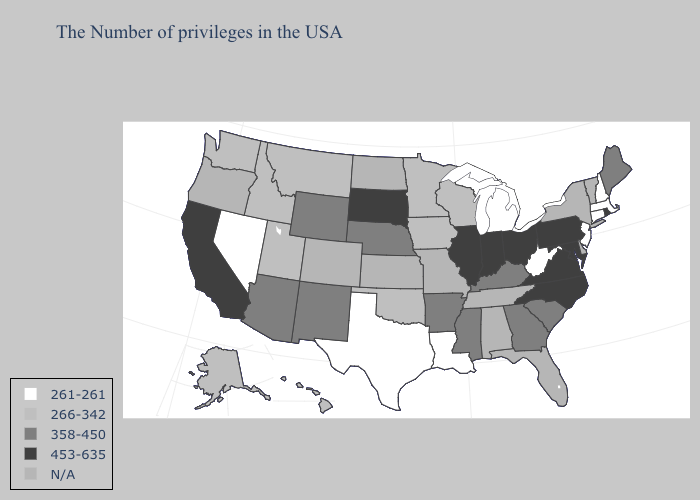What is the value of Montana?
Keep it brief. 266-342. Name the states that have a value in the range 261-261?
Be succinct. Massachusetts, New Hampshire, Connecticut, New Jersey, West Virginia, Michigan, Louisiana, Texas, Nevada. What is the lowest value in states that border Maryland?
Answer briefly. 261-261. Which states have the highest value in the USA?
Be succinct. Rhode Island, Maryland, Pennsylvania, Virginia, North Carolina, Ohio, Indiana, Illinois, South Dakota, California. What is the value of New Hampshire?
Be succinct. 261-261. Does Rhode Island have the highest value in the USA?
Give a very brief answer. Yes. What is the value of South Carolina?
Write a very short answer. 358-450. Which states have the lowest value in the USA?
Give a very brief answer. Massachusetts, New Hampshire, Connecticut, New Jersey, West Virginia, Michigan, Louisiana, Texas, Nevada. What is the highest value in states that border Tennessee?
Be succinct. 453-635. Name the states that have a value in the range 266-342?
Concise answer only. Wisconsin, Minnesota, Iowa, Oklahoma, Utah, Montana, Idaho, Washington, Alaska, Hawaii. Does Maryland have the highest value in the USA?
Short answer required. Yes. 